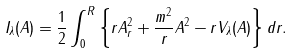<formula> <loc_0><loc_0><loc_500><loc_500>I _ { \lambda } ( A ) = \frac { 1 } { 2 } \int _ { 0 } ^ { R } \left \{ r A _ { r } ^ { 2 } + \frac { m ^ { 2 } } { r } A ^ { 2 } - r V _ { \lambda } ( A ) \right \} d r .</formula> 